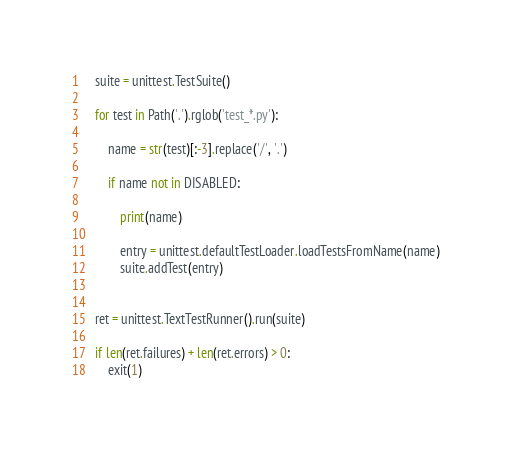Convert code to text. <code><loc_0><loc_0><loc_500><loc_500><_Python_>    suite = unittest.TestSuite()
    
    for test in Path('.').rglob('test_*.py'):

        name = str(test)[:-3].replace('/', '.')

        if name not in DISABLED:

            print(name)

            entry = unittest.defaultTestLoader.loadTestsFromName(name)
            suite.addTest(entry)


    ret = unittest.TextTestRunner().run(suite)

    if len(ret.failures) + len(ret.errors) > 0:
        exit(1)</code> 